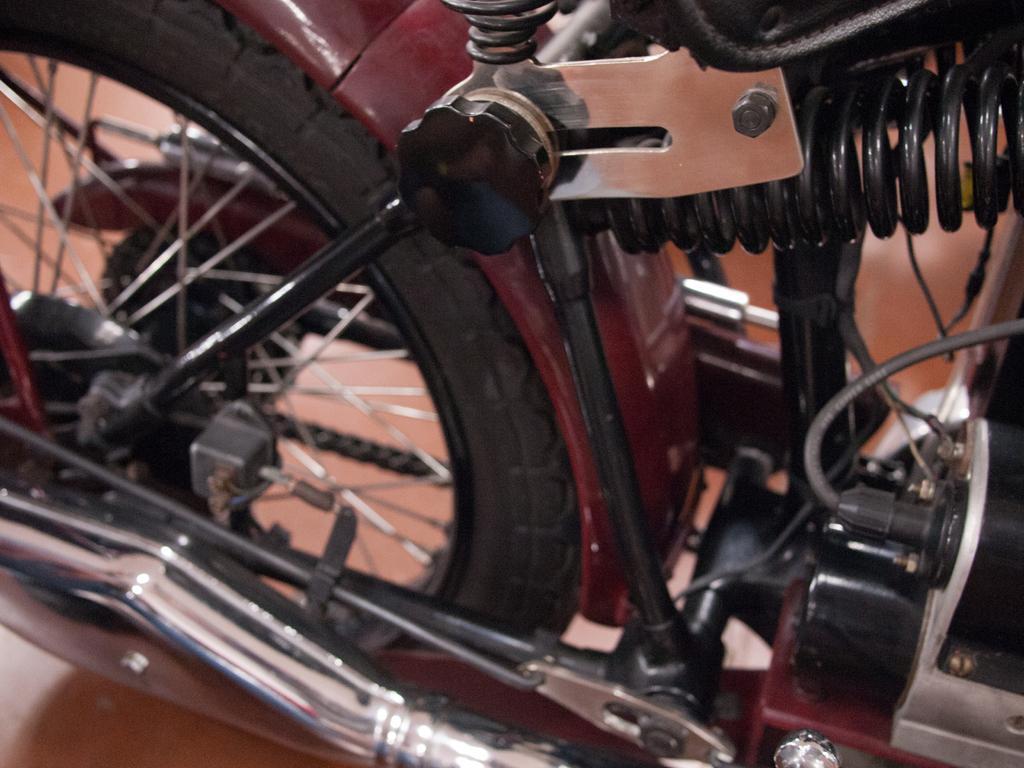How would you summarize this image in a sentence or two? In the image we can see a bike and this is a tire of the bike. This is a floor. 